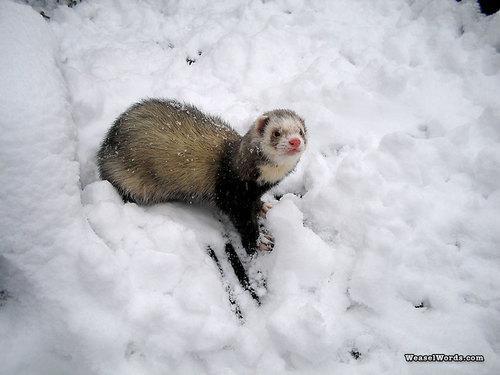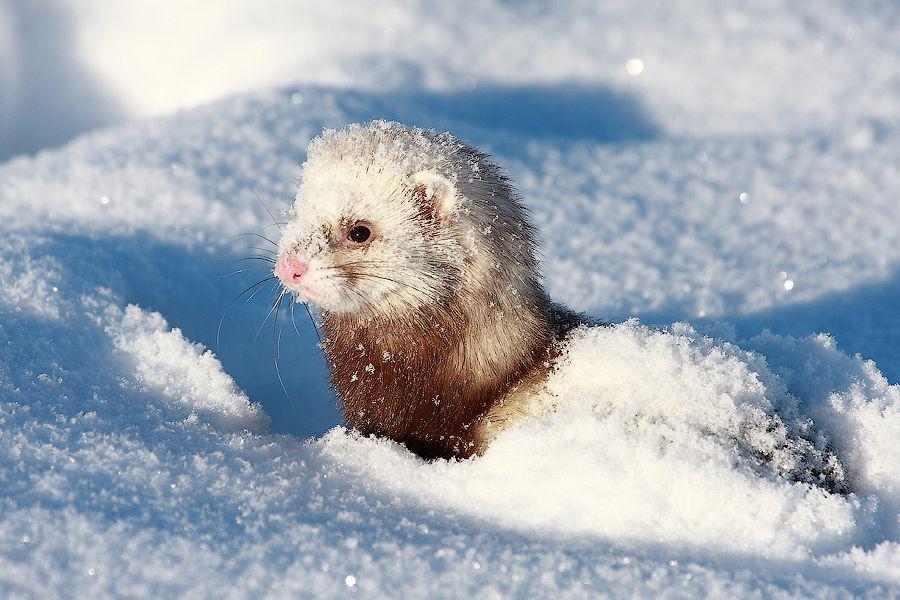The first image is the image on the left, the second image is the image on the right. For the images displayed, is the sentence "The animal in the right image is not in the snow." factually correct? Answer yes or no. No. The first image is the image on the left, the second image is the image on the right. Analyze the images presented: Is the assertion "The right image has a ferret peeking out of the snow." valid? Answer yes or no. Yes. 